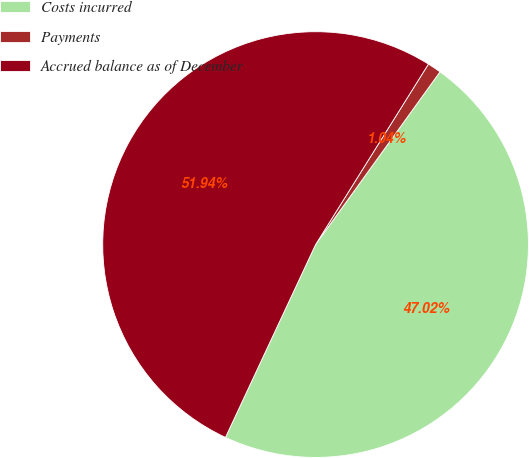<chart> <loc_0><loc_0><loc_500><loc_500><pie_chart><fcel>Costs incurred<fcel>Payments<fcel>Accrued balance as of December<nl><fcel>47.02%<fcel>1.04%<fcel>51.93%<nl></chart> 